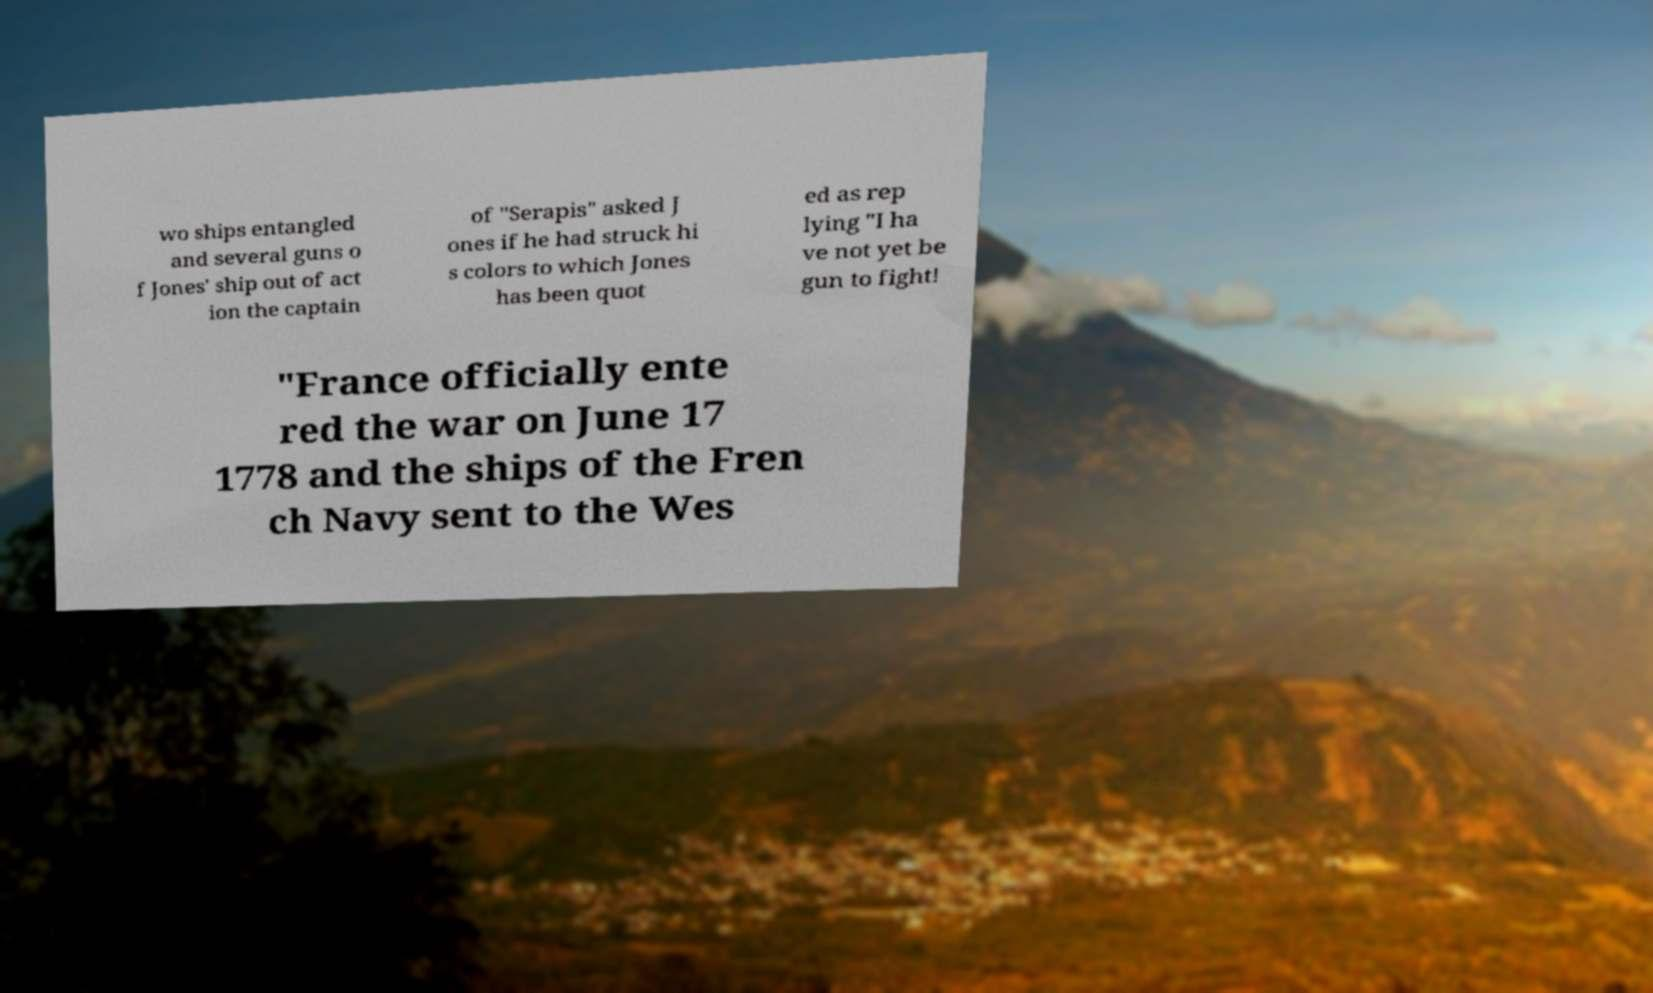For documentation purposes, I need the text within this image transcribed. Could you provide that? wo ships entangled and several guns o f Jones' ship out of act ion the captain of "Serapis" asked J ones if he had struck hi s colors to which Jones has been quot ed as rep lying "I ha ve not yet be gun to fight! "France officially ente red the war on June 17 1778 and the ships of the Fren ch Navy sent to the Wes 